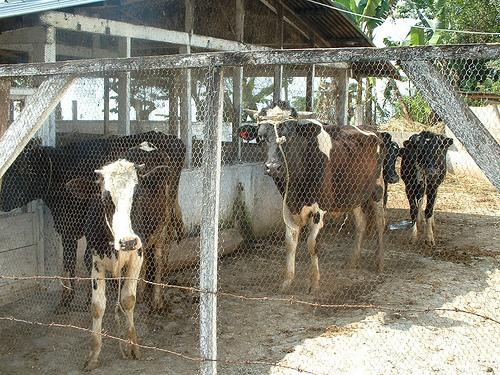The nearby cow to the left who is looking at the camera wears what color down his face? Please explain your reasoning. white. The cow's face is not black, brown, or gray. 